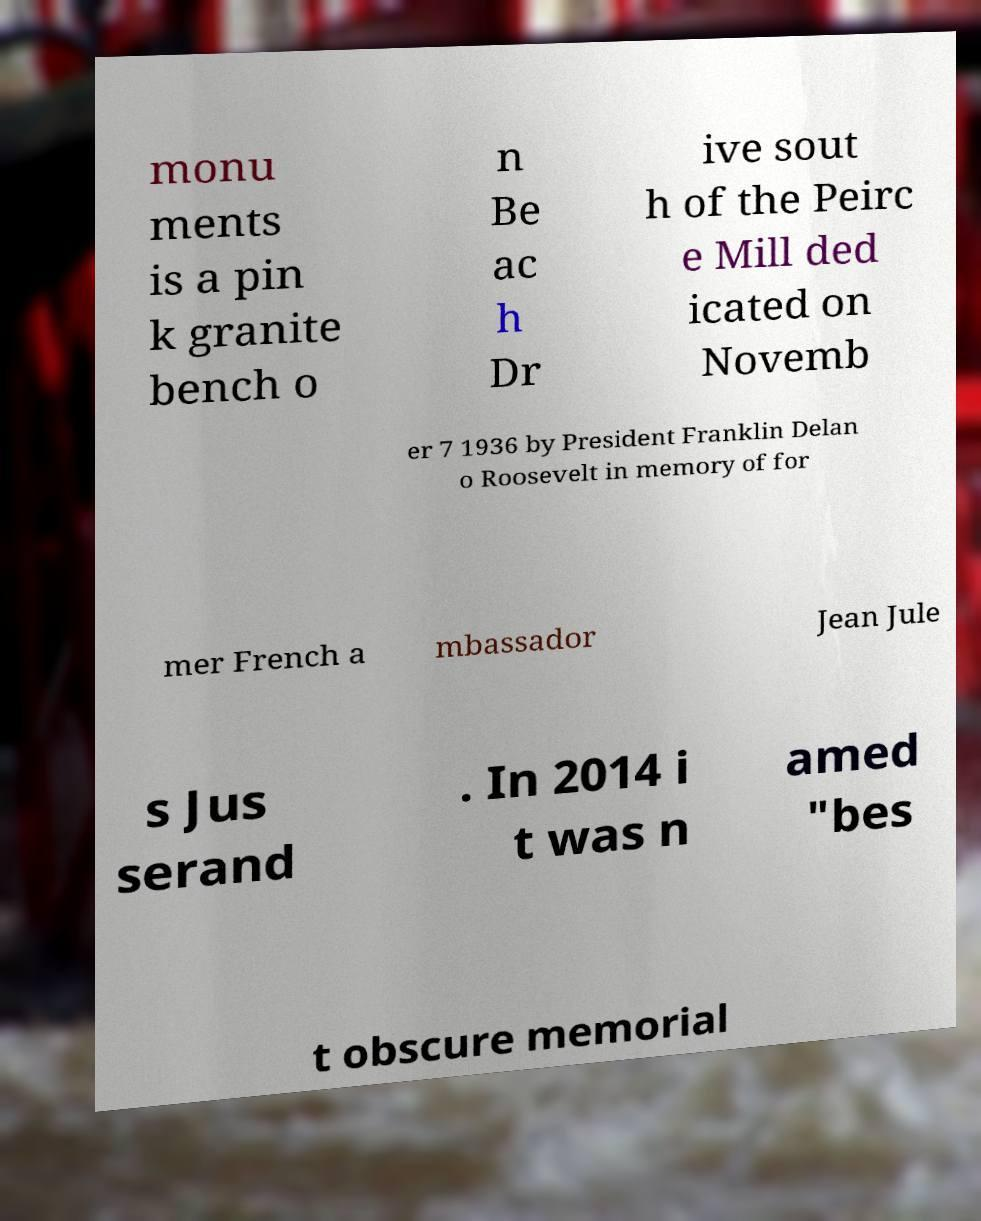Can you accurately transcribe the text from the provided image for me? monu ments is a pin k granite bench o n Be ac h Dr ive sout h of the Peirc e Mill ded icated on Novemb er 7 1936 by President Franklin Delan o Roosevelt in memory of for mer French a mbassador Jean Jule s Jus serand . In 2014 i t was n amed "bes t obscure memorial 